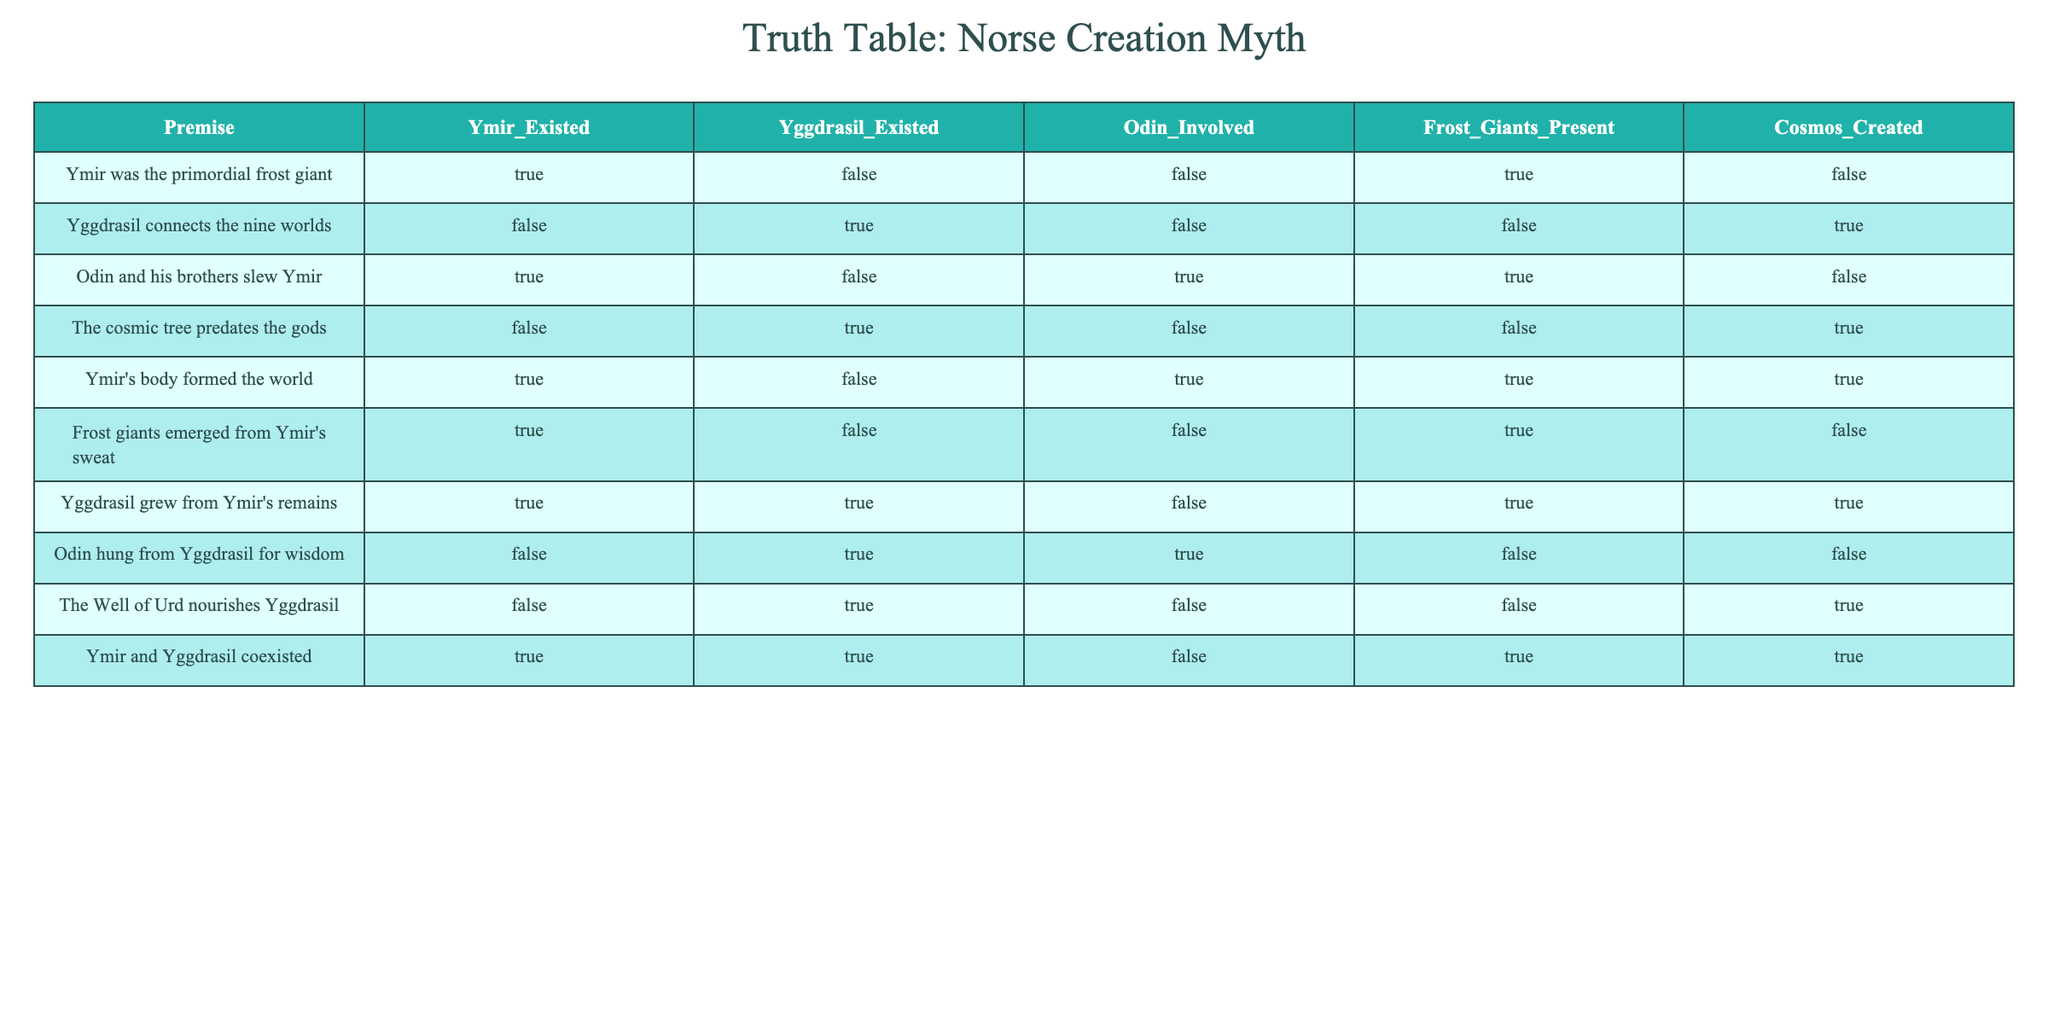What is the premise regarding Ymir's existence? According to the table, the premise states that "Ymir was the primordial frost giant," which corresponds to the column under "Ymir_Existed" showing TRUE.
Answer: TRUE Did Yggdrasil exist when Ymir was alive? The table indicates that Ymir and Yggdrasil coexisted, with both labeled TRUE under their respective columns. Therefore, Yggdrasil existed when Ymir was alive.
Answer: YES What are the total number of times Odin is involved in the events described in the table? By counting the rows where Odin is indicated as involved (Odin_Involved is TRUE), we find three occurrences: "Odin and his brothers slew Ymir," "Odin hung from Yggdrasil for wisdom," and "Ymir's body formed the world." Thus, the total is 3.
Answer: 3 Is it true that the cosmic tree grew from Ymir's remains? The relevant premise states "Yggdrasil grew from Ymir's remains," and under the Yggdrasil_Existed column, it shows TRUE. Therefore, the statement is true.
Answer: YES How many premises indicate that the cosmos was created? The table shows that under the "Cosmos_Created" column, only Ymir's body formed the world corresponds to TRUE. Since there is only one TRUE value, the total is 1.
Answer: 1 What does the premise "Frost giants emerged from Ymir's sweat" imply about Ymir's role? The premise indicates that the existence of frost giants is tied to Ymir, suggesting he is a progenitor figure in this context. Since it is marked TRUE under "Frost_Giants_Present," it reflects Ymir's essential role in the creation myth.
Answer: Ymir is a progenitor Is it valid to say that every time Yggdrasil is mentioned, it also states that it connects to the nine worlds? By examining the table, we find that Yggdrasil is mentioned multiple times, but only in the row indicating it connects the nine worlds does it appear TRUE (under Yggdrasil_Existed), while other premises have different implications for its existence. Therefore, it's not valid.
Answer: NO What is the connection between Odin's involvement and the creation of the cosmos? Odin's involvement relates to one premise - that he and his brothers slew Ymir. In this case, the cosmos was not created (indicated as FALSE). Therefore, while Odin's involvement exists, it does not directly correlate to the cosmos’ creation.
Answer: They are not directly connected Contrast the existence of Ymir with Yggdrasil in the context of being precursory. The table shows that Ymir existed as a being, while Yggdrasil is identified through its existence as part of several premises. Yggdrasil is implied to predate elements of the cosmos, while Ymir's existence appears finite to his contribution to creation.
Answer: Ymir was finite; Yggdrasil is considered precursory 